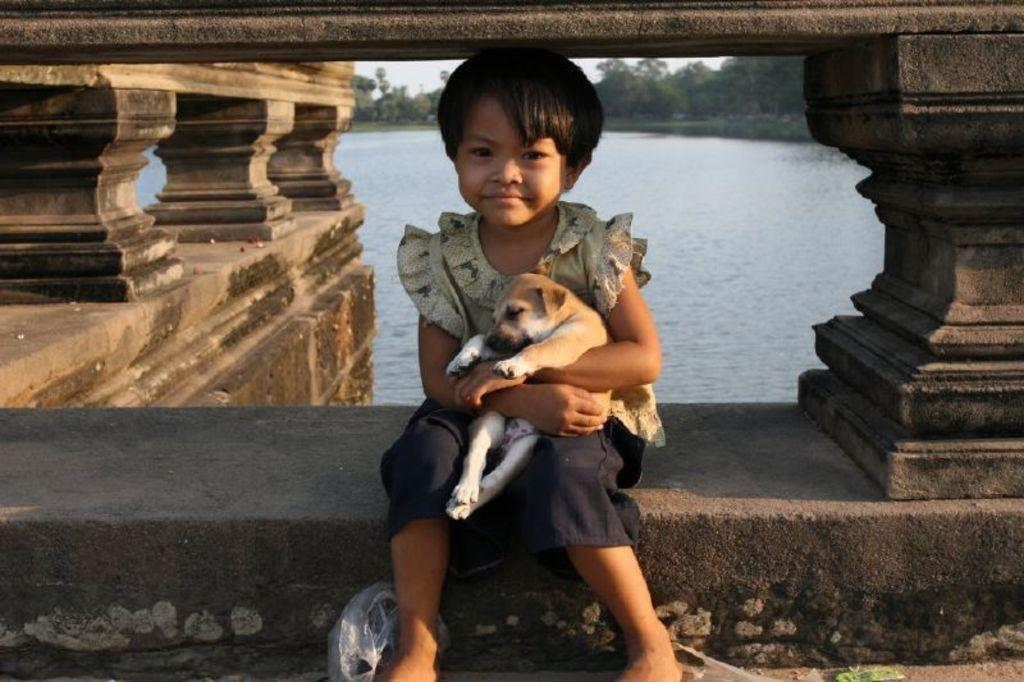Who is in the image? There is a girl in the image. What is the girl holding? The girl is holding a puppy. Where is the girl sitting? The girl is sitting on the wall of a river. What can be seen in the background of the image? There are small pillars, a river, and trees in the background of the image. Can you see any spots on the girl's dress in the image? There is no mention of spots on the girl's dress in the provided facts, so we cannot answer this question definitively. --- Facts: 1. There is a car in the image. 2. The car is red. 3. The car has four wheels. 4. There is a road in the image. 5. The road is paved. 6. There are trees on the side of the road. Absurd Topics: parrot, dance, mountain Conversation: What is the main subject of the image? The main subject of the image is a car. What color is the car? The car is red. How many wheels does the car have? The car has four wheels. What is the surface of the road in the image? The road is paved. What can be seen on the side of the road? There are trees on the side of the road. Reasoning: Let's think step by step in order to produce the conversation. We start by identifying the main subject in the image, which is the car. Then, we expand the conversation to include the color and number of wheels on the car. Next, we describe the road in the image, including its surface and the trees on the side of the road. Each question is designed to elicit a specific detail about the image that is known from the provided facts. Absurd Question/Answer: Can you see a parrot dancing on the roof of the car in the image? There is no mention of a parrot or dancing in the provided facts, so we cannot answer this question definitively. 